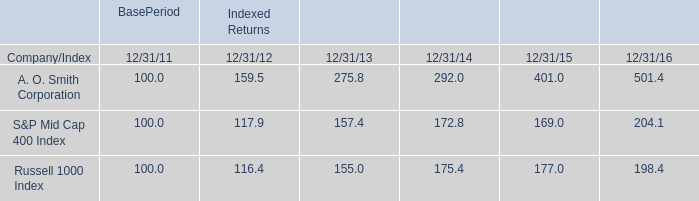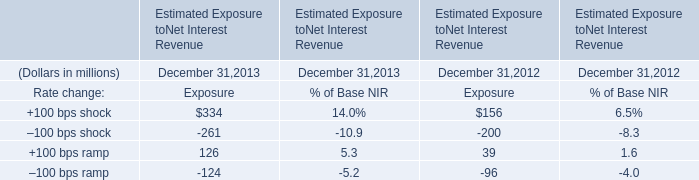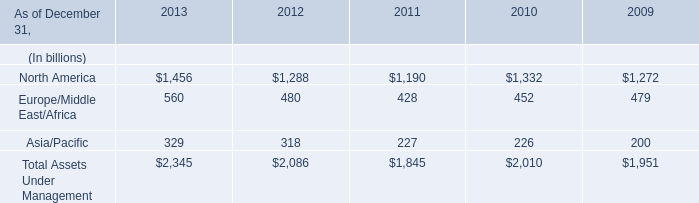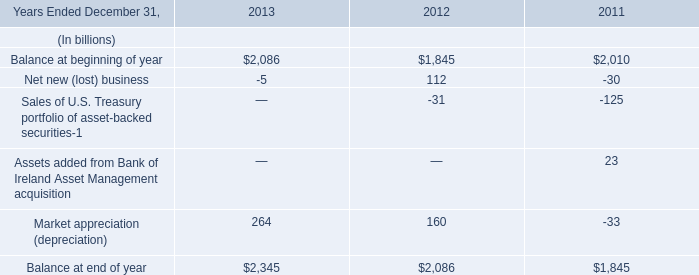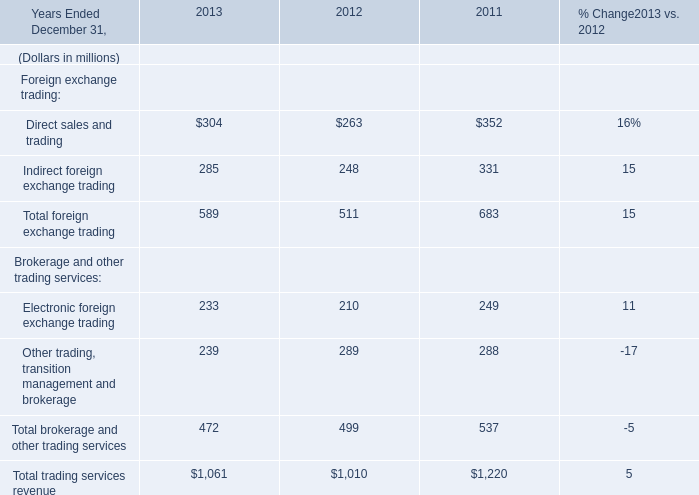In the year with the most North America, what is the growth rate of North America? 
Computations: ((1456 - 1288) / 1456)
Answer: 0.11538. 